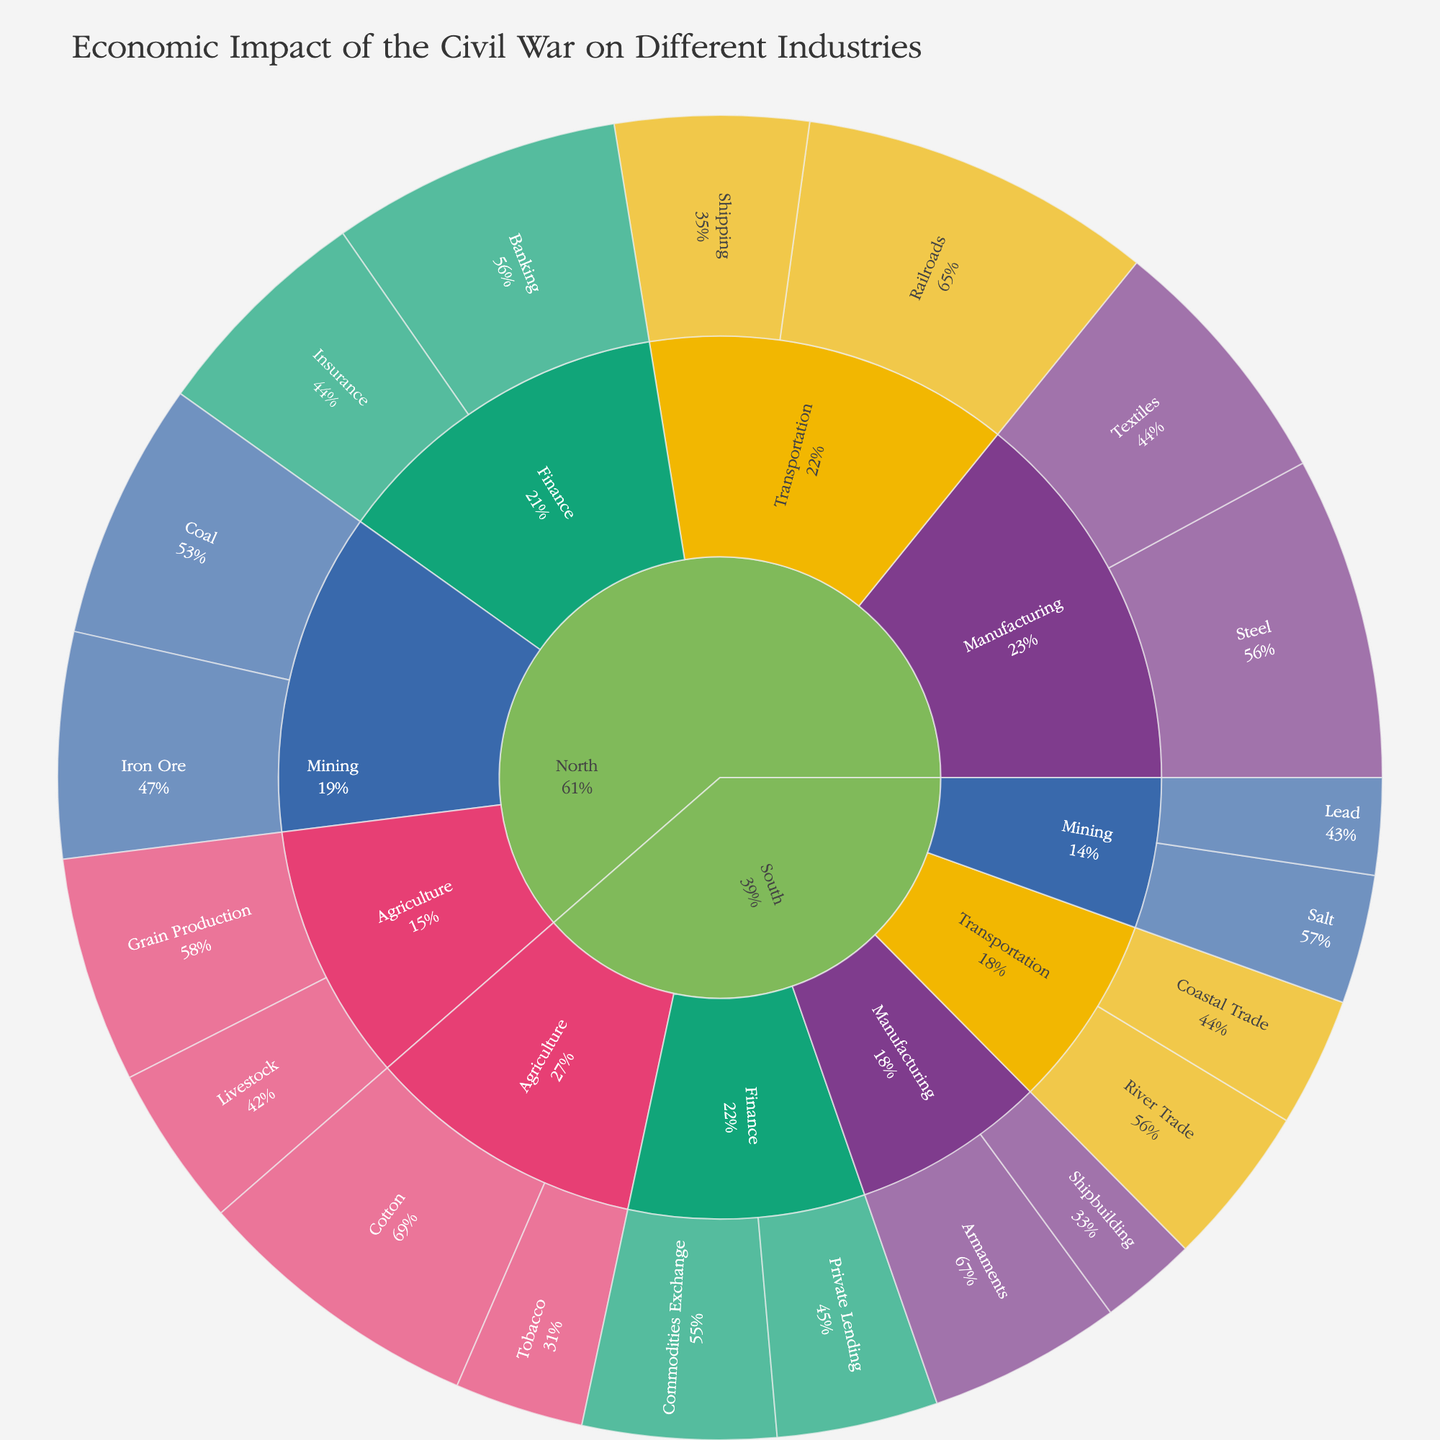What's the overall economic impact of the Civil War on the Agriculture industry? First, locate the "Agriculture" section in the plot. Then, sum up all the values for both the North and the South: 35 (Grain Production) + 25 (Livestock) + 45 (Cotton) + 20 (Tobacco). Thus, the overall economic impact is 125.
Answer: 125 Which region has a higher economic impact in the Finance industry? Check the values under the Finance industry for both regions. The North has Banking (45) + Insurance (35) = 80, while the South has Commodities Exchange (30) + Private Lending (25) = 55. Therefore, the North has a higher economic impact.
Answer: North What percentage of the North's Transportation economic impact comes from Railroads? Find the total value for Transportation in the North: Railroads (55) + Shipping (30) = 85. Then, divide the value for Railroads by the total and multiply by 100: (55 / 85) * 100 ≈ 64.7%.
Answer: 64.7% Which sector within the South's Manufacturing industry has a lower economic impact? Compare the values within the South's Manufacturing sectors: Shipbuilding (15) and Armaments (30). Shipbuilding has the lower economic impact.
Answer: Shipbuilding If you combine the North's and South's economic impacts in Mining, what is the total value? Locate the values for Mining in both regions: North has Coal (40) + Iron Ore (35) = 75, and South has Salt (20) + Lead (15) = 35. Summing them gives 75 + 35 = 110.
Answer: 110 What is the dominant industry in the South based on economic impact? Examine all the industries' total values in the South: Agriculture (45 + 20 = 65), Manufacturing (15 + 30 = 45), Transportation (25 + 20 = 45), Finance (30 + 25 = 55), and Mining (20 + 15 = 35). Agriculture has the highest total value of 65.
Answer: Agriculture Which sector in the North’s Manufacturing industry contributes most to its economic impact? Look at the sectors in the North's Manufacturing industry: Textiles (40) and Steel (50). Steel has the higher value.
Answer: Steel What is the comparative difference in economic impact between Cotton in the South and Steel in the North? Identify the values: Cotton (South) = 45 and Steel (North) = 50. The difference is 50 - 45 = 5.
Answer: 5 